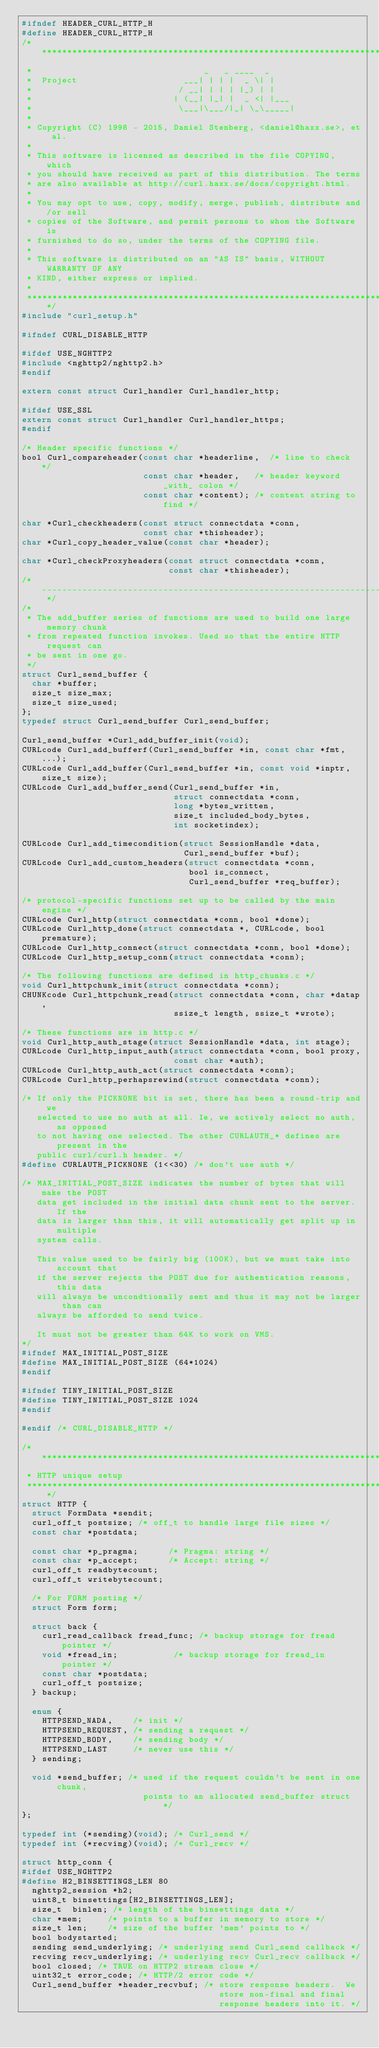<code> <loc_0><loc_0><loc_500><loc_500><_C_>#ifndef HEADER_CURL_HTTP_H
#define HEADER_CURL_HTTP_H
/***************************************************************************
 *                                  _   _ ____  _
 *  Project                     ___| | | |  _ \| |
 *                             / __| | | | |_) | |
 *                            | (__| |_| |  _ <| |___
 *                             \___|\___/|_| \_\_____|
 *
 * Copyright (C) 1998 - 2015, Daniel Stenberg, <daniel@haxx.se>, et al.
 *
 * This software is licensed as described in the file COPYING, which
 * you should have received as part of this distribution. The terms
 * are also available at http://curl.haxx.se/docs/copyright.html.
 *
 * You may opt to use, copy, modify, merge, publish, distribute and/or sell
 * copies of the Software, and permit persons to whom the Software is
 * furnished to do so, under the terms of the COPYING file.
 *
 * This software is distributed on an "AS IS" basis, WITHOUT WARRANTY OF ANY
 * KIND, either express or implied.
 *
 ***************************************************************************/
#include "curl_setup.h"

#ifndef CURL_DISABLE_HTTP

#ifdef USE_NGHTTP2
#include <nghttp2/nghttp2.h>
#endif

extern const struct Curl_handler Curl_handler_http;

#ifdef USE_SSL
extern const struct Curl_handler Curl_handler_https;
#endif

/* Header specific functions */
bool Curl_compareheader(const char *headerline,  /* line to check */
                        const char *header,   /* header keyword _with_ colon */
                        const char *content); /* content string to find */

char *Curl_checkheaders(const struct connectdata *conn,
                        const char *thisheader);
char *Curl_copy_header_value(const char *header);

char *Curl_checkProxyheaders(const struct connectdata *conn,
                             const char *thisheader);
/* ------------------------------------------------------------------------- */
/*
 * The add_buffer series of functions are used to build one large memory chunk
 * from repeated function invokes. Used so that the entire HTTP request can
 * be sent in one go.
 */
struct Curl_send_buffer {
  char *buffer;
  size_t size_max;
  size_t size_used;
};
typedef struct Curl_send_buffer Curl_send_buffer;

Curl_send_buffer *Curl_add_buffer_init(void);
CURLcode Curl_add_bufferf(Curl_send_buffer *in, const char *fmt, ...);
CURLcode Curl_add_buffer(Curl_send_buffer *in, const void *inptr, size_t size);
CURLcode Curl_add_buffer_send(Curl_send_buffer *in,
                              struct connectdata *conn,
                              long *bytes_written,
                              size_t included_body_bytes,
                              int socketindex);

CURLcode Curl_add_timecondition(struct SessionHandle *data,
                                Curl_send_buffer *buf);
CURLcode Curl_add_custom_headers(struct connectdata *conn,
                                 bool is_connect,
                                 Curl_send_buffer *req_buffer);

/* protocol-specific functions set up to be called by the main engine */
CURLcode Curl_http(struct connectdata *conn, bool *done);
CURLcode Curl_http_done(struct connectdata *, CURLcode, bool premature);
CURLcode Curl_http_connect(struct connectdata *conn, bool *done);
CURLcode Curl_http_setup_conn(struct connectdata *conn);

/* The following functions are defined in http_chunks.c */
void Curl_httpchunk_init(struct connectdata *conn);
CHUNKcode Curl_httpchunk_read(struct connectdata *conn, char *datap,
                              ssize_t length, ssize_t *wrote);

/* These functions are in http.c */
void Curl_http_auth_stage(struct SessionHandle *data, int stage);
CURLcode Curl_http_input_auth(struct connectdata *conn, bool proxy,
                              const char *auth);
CURLcode Curl_http_auth_act(struct connectdata *conn);
CURLcode Curl_http_perhapsrewind(struct connectdata *conn);

/* If only the PICKNONE bit is set, there has been a round-trip and we
   selected to use no auth at all. Ie, we actively select no auth, as opposed
   to not having one selected. The other CURLAUTH_* defines are present in the
   public curl/curl.h header. */
#define CURLAUTH_PICKNONE (1<<30) /* don't use auth */

/* MAX_INITIAL_POST_SIZE indicates the number of bytes that will make the POST
   data get included in the initial data chunk sent to the server. If the
   data is larger than this, it will automatically get split up in multiple
   system calls.

   This value used to be fairly big (100K), but we must take into account that
   if the server rejects the POST due for authentication reasons, this data
   will always be uncondtionally sent and thus it may not be larger than can
   always be afforded to send twice.

   It must not be greater than 64K to work on VMS.
*/
#ifndef MAX_INITIAL_POST_SIZE
#define MAX_INITIAL_POST_SIZE (64*1024)
#endif

#ifndef TINY_INITIAL_POST_SIZE
#define TINY_INITIAL_POST_SIZE 1024
#endif

#endif /* CURL_DISABLE_HTTP */

/****************************************************************************
 * HTTP unique setup
 ***************************************************************************/
struct HTTP {
  struct FormData *sendit;
  curl_off_t postsize; /* off_t to handle large file sizes */
  const char *postdata;

  const char *p_pragma;      /* Pragma: string */
  const char *p_accept;      /* Accept: string */
  curl_off_t readbytecount;
  curl_off_t writebytecount;

  /* For FORM posting */
  struct Form form;

  struct back {
    curl_read_callback fread_func; /* backup storage for fread pointer */
    void *fread_in;           /* backup storage for fread_in pointer */
    const char *postdata;
    curl_off_t postsize;
  } backup;

  enum {
    HTTPSEND_NADA,    /* init */
    HTTPSEND_REQUEST, /* sending a request */
    HTTPSEND_BODY,    /* sending body */
    HTTPSEND_LAST     /* never use this */
  } sending;

  void *send_buffer; /* used if the request couldn't be sent in one chunk,
                        points to an allocated send_buffer struct */
};

typedef int (*sending)(void); /* Curl_send */
typedef int (*recving)(void); /* Curl_recv */

struct http_conn {
#ifdef USE_NGHTTP2
#define H2_BINSETTINGS_LEN 80
  nghttp2_session *h2;
  uint8_t binsettings[H2_BINSETTINGS_LEN];
  size_t  binlen; /* length of the binsettings data */
  char *mem;     /* points to a buffer in memory to store */
  size_t len;    /* size of the buffer 'mem' points to */
  bool bodystarted;
  sending send_underlying; /* underlying send Curl_send callback */
  recving recv_underlying; /* underlying recv Curl_recv callback */
  bool closed; /* TRUE on HTTP2 stream close */
  uint32_t error_code; /* HTTP/2 error code */
  Curl_send_buffer *header_recvbuf; /* store response headers.  We
                                       store non-final and final
                                       response headers into it. */</code> 